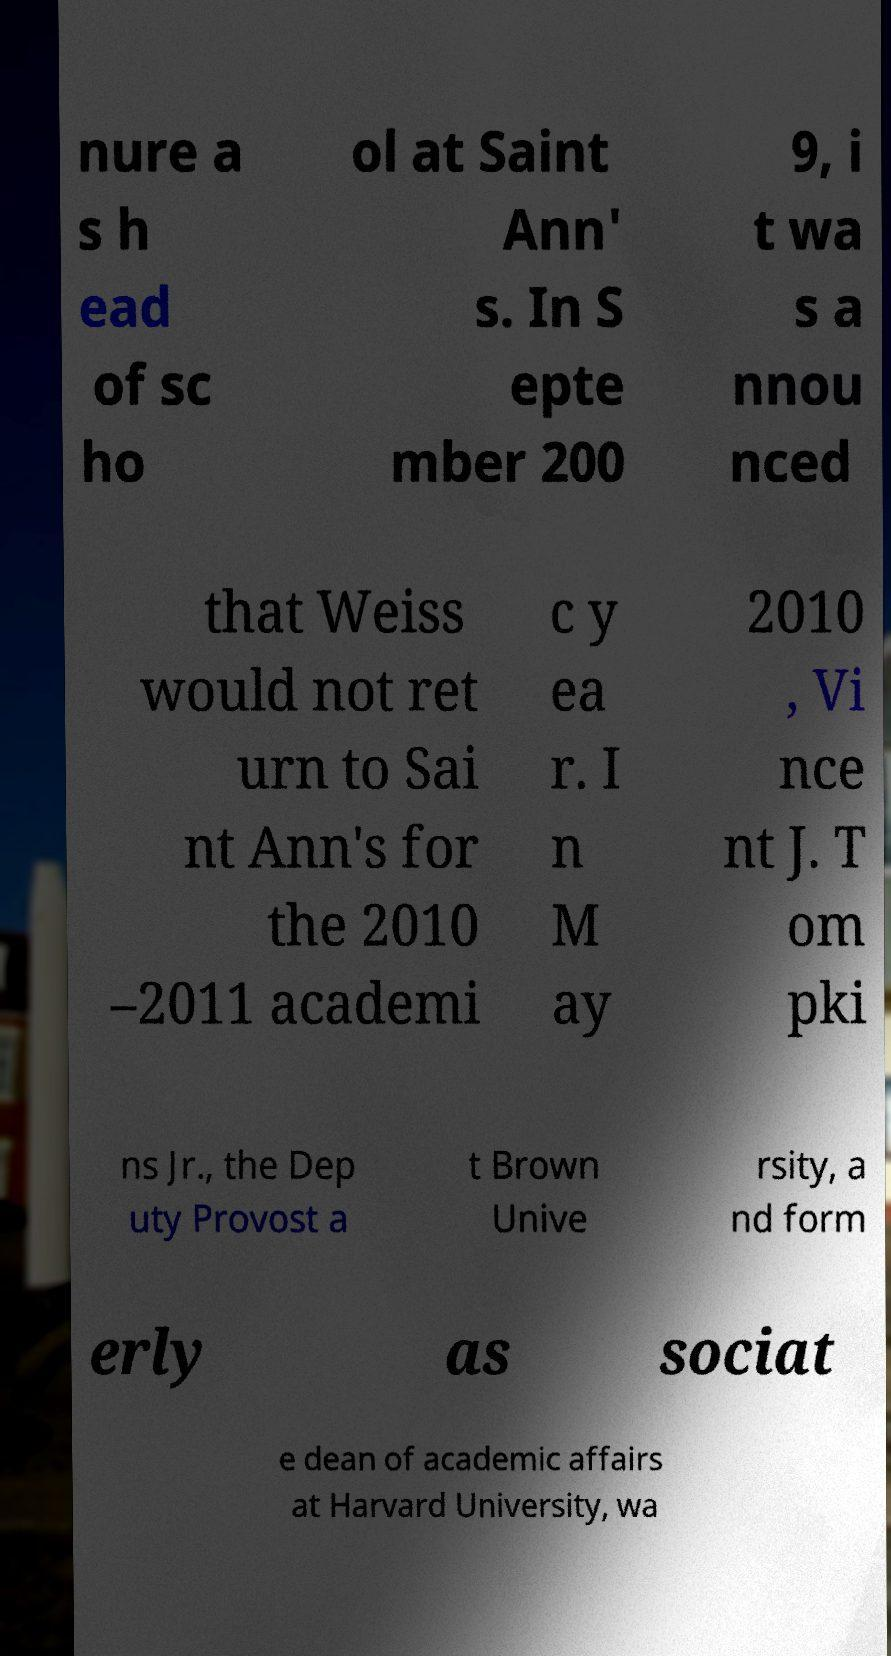There's text embedded in this image that I need extracted. Can you transcribe it verbatim? nure a s h ead of sc ho ol at Saint Ann' s. In S epte mber 200 9, i t wa s a nnou nced that Weiss would not ret urn to Sai nt Ann's for the 2010 –2011 academi c y ea r. I n M ay 2010 , Vi nce nt J. T om pki ns Jr., the Dep uty Provost a t Brown Unive rsity, a nd form erly as sociat e dean of academic affairs at Harvard University, wa 